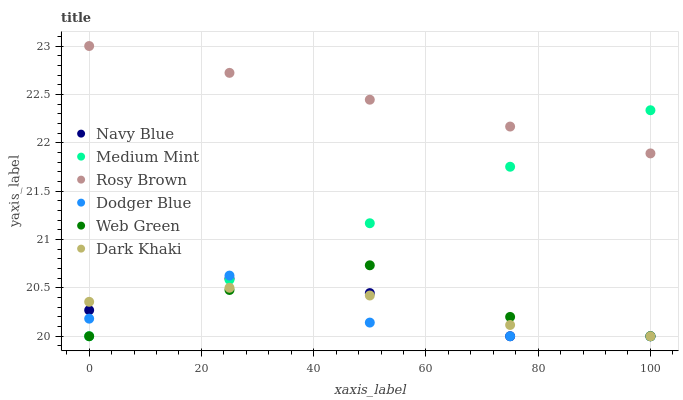Does Dodger Blue have the minimum area under the curve?
Answer yes or no. Yes. Does Rosy Brown have the maximum area under the curve?
Answer yes or no. Yes. Does Navy Blue have the minimum area under the curve?
Answer yes or no. No. Does Navy Blue have the maximum area under the curve?
Answer yes or no. No. Is Medium Mint the smoothest?
Answer yes or no. Yes. Is Dodger Blue the roughest?
Answer yes or no. Yes. Is Navy Blue the smoothest?
Answer yes or no. No. Is Navy Blue the roughest?
Answer yes or no. No. Does Medium Mint have the lowest value?
Answer yes or no. Yes. Does Rosy Brown have the lowest value?
Answer yes or no. No. Does Rosy Brown have the highest value?
Answer yes or no. Yes. Does Navy Blue have the highest value?
Answer yes or no. No. Is Dodger Blue less than Rosy Brown?
Answer yes or no. Yes. Is Rosy Brown greater than Dodger Blue?
Answer yes or no. Yes. Does Web Green intersect Dark Khaki?
Answer yes or no. Yes. Is Web Green less than Dark Khaki?
Answer yes or no. No. Is Web Green greater than Dark Khaki?
Answer yes or no. No. Does Dodger Blue intersect Rosy Brown?
Answer yes or no. No. 